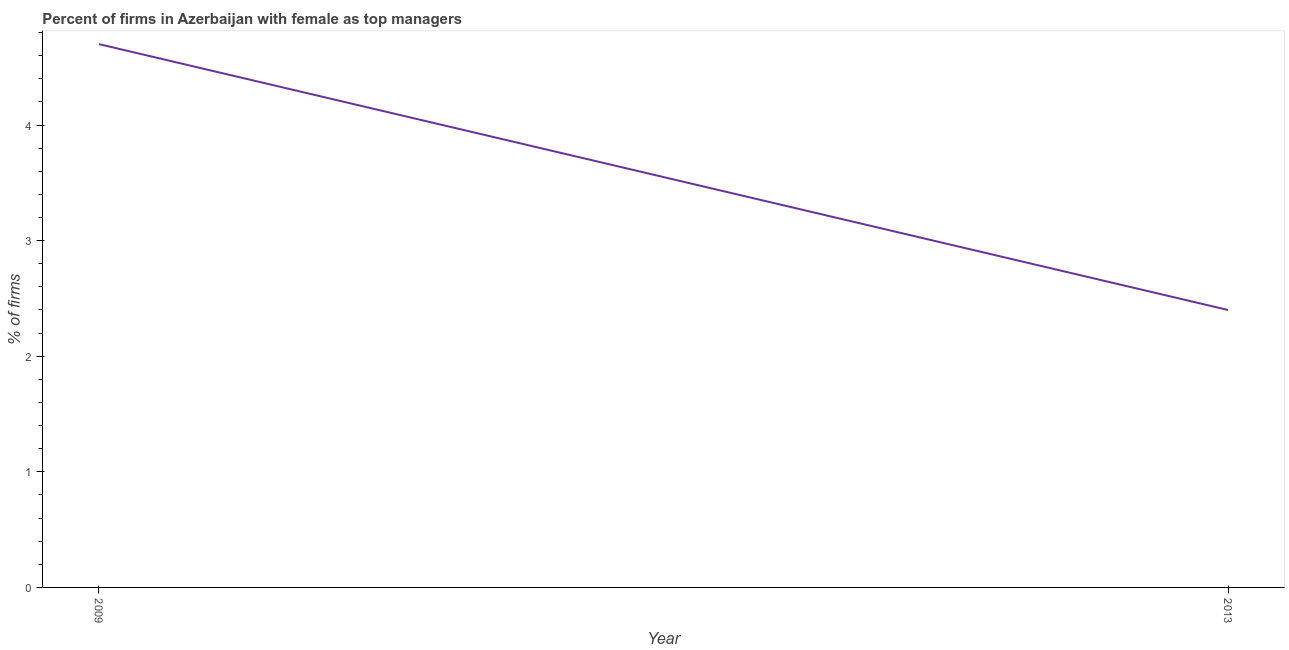Across all years, what is the maximum percentage of firms with female as top manager?
Give a very brief answer. 4.7. In which year was the percentage of firms with female as top manager minimum?
Keep it short and to the point. 2013. What is the difference between the percentage of firms with female as top manager in 2009 and 2013?
Your answer should be compact. 2.3. What is the average percentage of firms with female as top manager per year?
Give a very brief answer. 3.55. What is the median percentage of firms with female as top manager?
Give a very brief answer. 3.55. What is the ratio of the percentage of firms with female as top manager in 2009 to that in 2013?
Offer a very short reply. 1.96. Is the percentage of firms with female as top manager in 2009 less than that in 2013?
Provide a succinct answer. No. How many lines are there?
Your response must be concise. 1. Does the graph contain grids?
Make the answer very short. No. What is the title of the graph?
Your response must be concise. Percent of firms in Azerbaijan with female as top managers. What is the label or title of the Y-axis?
Make the answer very short. % of firms. What is the % of firms in 2009?
Give a very brief answer. 4.7. What is the ratio of the % of firms in 2009 to that in 2013?
Ensure brevity in your answer.  1.96. 